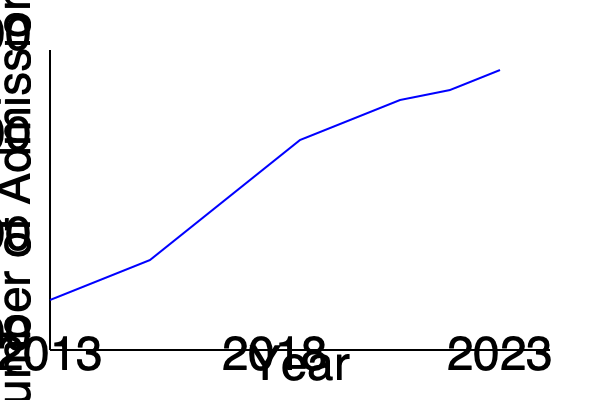Based on the line graph illustrating law school admissions from 2013 to 2023, what is the approximate percentage decrease in admissions over this period, and what potential factors could explain this trend? To answer this question, we need to follow these steps:

1. Identify the starting and ending points:
   - 2013 (start): approximately 52,000 admissions
   - 2023 (end): approximately 40,000 admissions

2. Calculate the percentage decrease:
   Percentage decrease = $\frac{\text{Decrease}}{\text{Original}} \times 100\%$
   
   $\frac{52,000 - 40,000}{52,000} \times 100\% = \frac{12,000}{52,000} \times 100\% \approx 23\%$

3. Potential factors explaining the trend:
   a) Increased competition in the legal job market
   b) Rising law school tuition costs
   c) Shift in career preferences among younger generations
   d) Changes in the perceived value of a law degree
   e) Economic factors affecting the legal industry

4. The trend shows a steady decline, which suggests long-term structural changes rather than short-term fluctuations.

5. As a future lawyer, it's important to consider how these trends might affect job prospects and the evolution of the legal profession.
Answer: Approximately 23% decrease; factors include job market competition, rising tuition, changing career preferences, perceived value of law degree, and economic factors affecting the legal industry. 